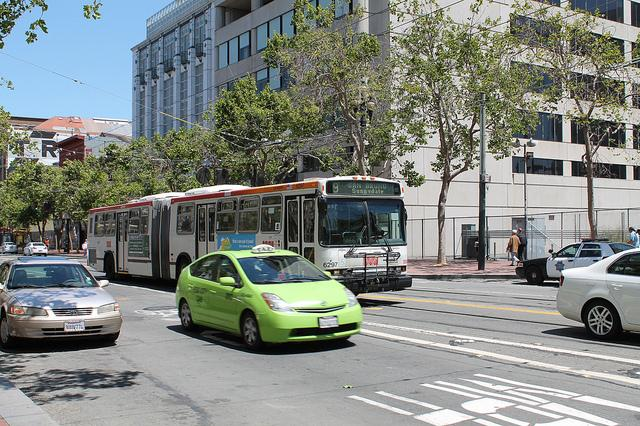Why is one car such a bright unusual color? taxi 